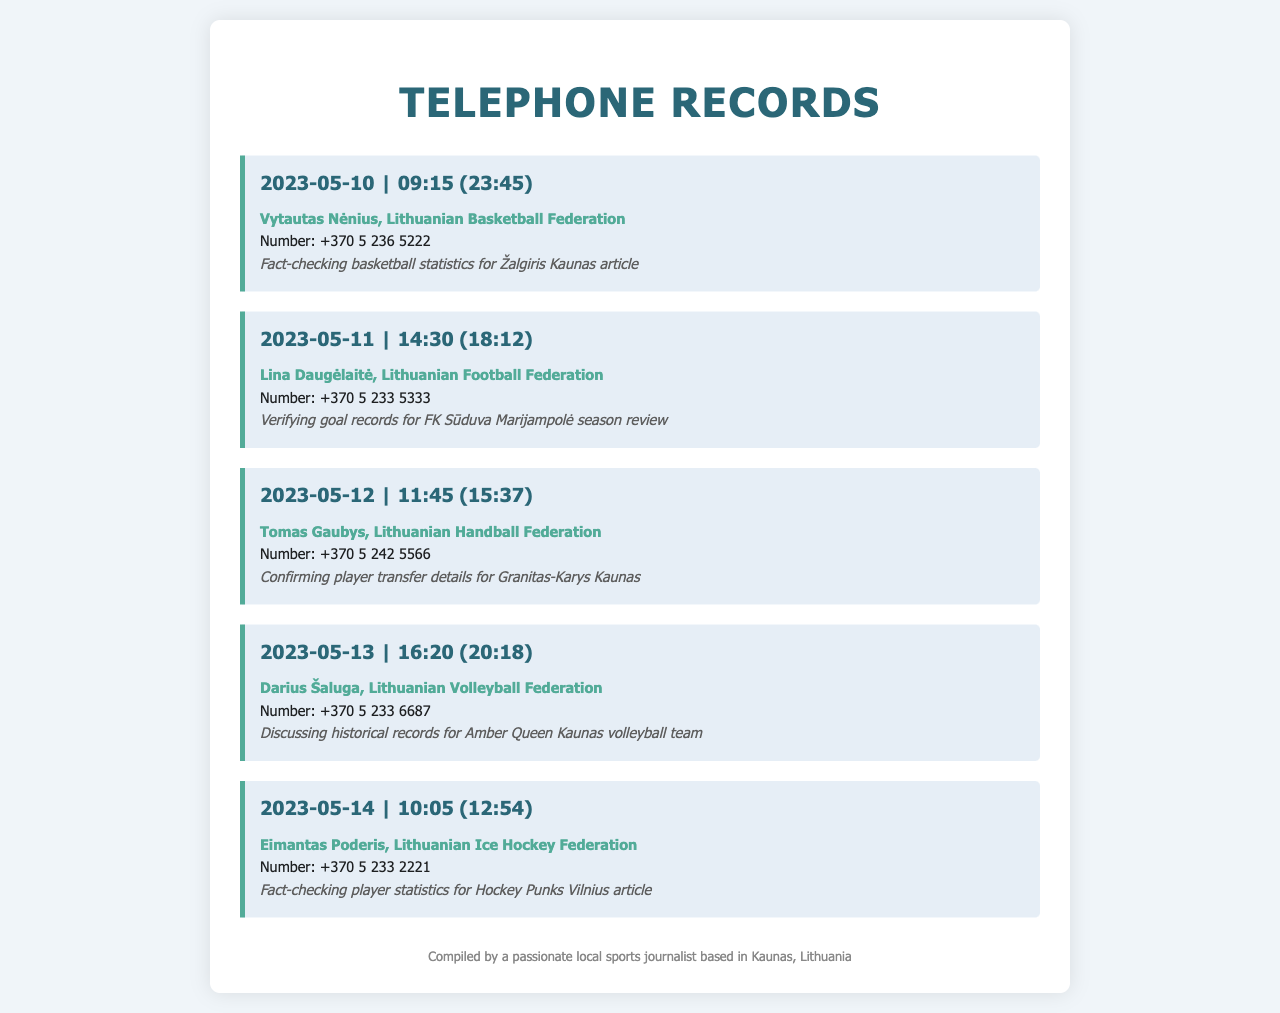What is the date of the call to Vytautas Nėnius? The date is mentioned in the record as 2023-05-10.
Answer: 2023-05-10 Who did the call on May 11 concern? The record states that the call was to Lina Daugėlaitė from the Lithuanian Football Federation.
Answer: Lina Daugėlaitė What was the purpose of the call made on May 12? The purpose is described as confirming player transfer details for Granitas-Karys Kaunas.
Answer: Confirming player transfer details for Granitas-Karys Kaunas How long was the call to Darius Šaluga? The duration is indicated in the format (hh:mm) as 20:18, which corresponds to a call duration of 3 hours and 58 minutes.
Answer: 3 hours and 58 minutes What time did the call to Eimantas Poderis take place? The time of the call is given as 10:05.
Answer: 10:05 Which sports federation was involved in the May 13 call? The document specifies that the call was with the Lithuanian Volleyball Federation.
Answer: Lithuanian Volleyball Federation How many calls were made for fact-checking purposes? By reviewing the document, three calls are specifically for fact-checking.
Answer: Three What is the profession of the caller mentioned in the footer? The footer describes the caller as a passionate local sports journalist.
Answer: Sports journalist 